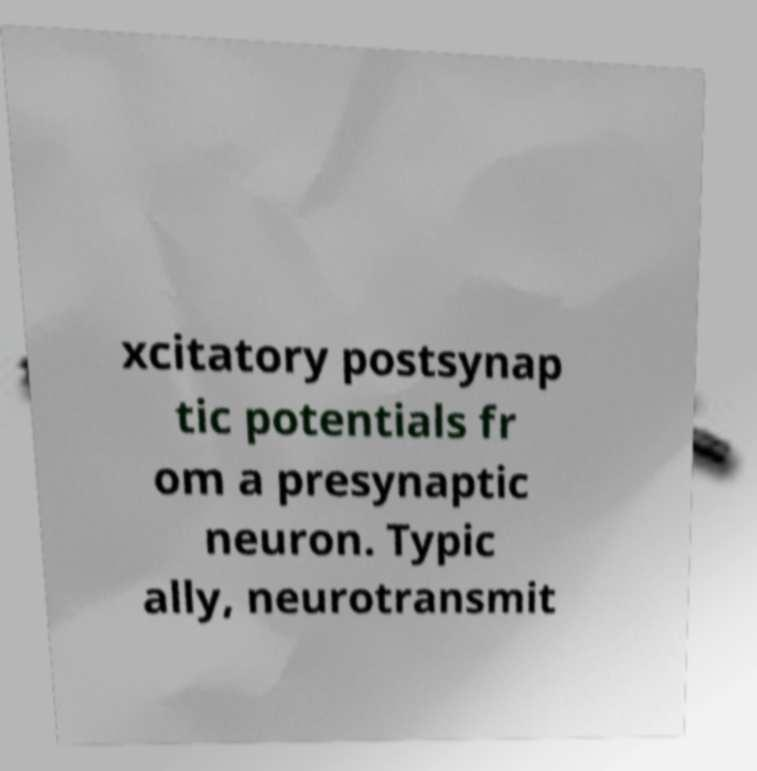What messages or text are displayed in this image? I need them in a readable, typed format. xcitatory postsynap tic potentials fr om a presynaptic neuron. Typic ally, neurotransmit 